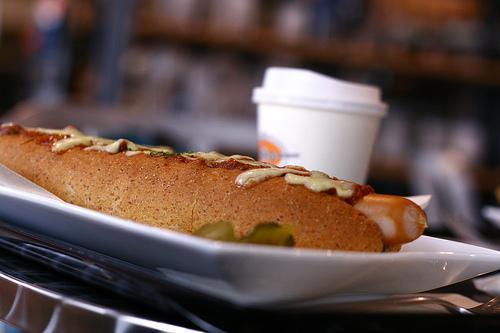How many cups are there?
Give a very brief answer. 1. 